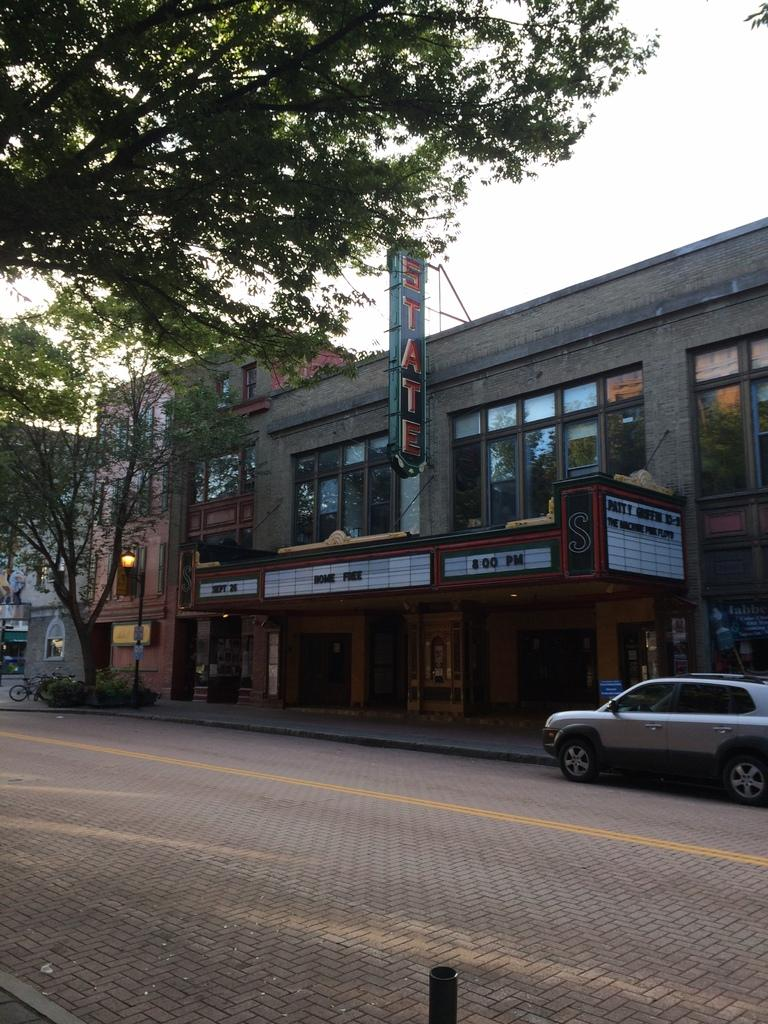What type of structures can be seen in the image? There are buildings in the image. What other natural elements are present in the image? There are trees in the image. What objects can be seen on the ground in the image? There are boards, a bicycle on the left side, and a car on the right side in the image. What vertical object is present in the image? There is a pole in the image. What is visible in the background of the image? The sky is visible in the background of the image. How many jellyfish are swimming in the sky in the image? There are no jellyfish present in the image, and the sky is visible in the background. What type of knee support is visible on the car in the image? There is no knee support visible on the car in the image; it is a regular car. 